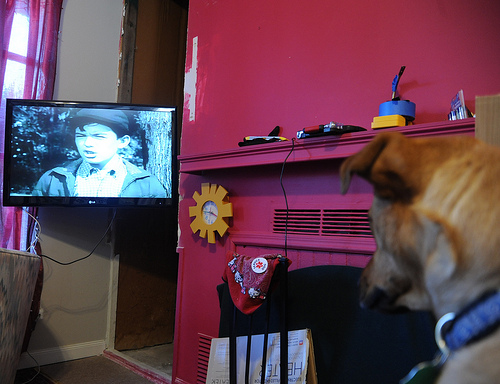<image>
Can you confirm if the dog is to the right of the tv? Yes. From this viewpoint, the dog is positioned to the right side relative to the tv. 